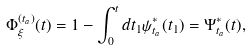<formula> <loc_0><loc_0><loc_500><loc_500>\Phi _ { \xi } ^ { ( t _ { a } ) } ( t ) = 1 - \int _ { 0 } ^ { t } d t _ { 1 } \psi _ { t _ { a } } ^ { * } ( t _ { 1 } ) = \Psi _ { t _ { a } } ^ { * } ( t ) ,</formula> 